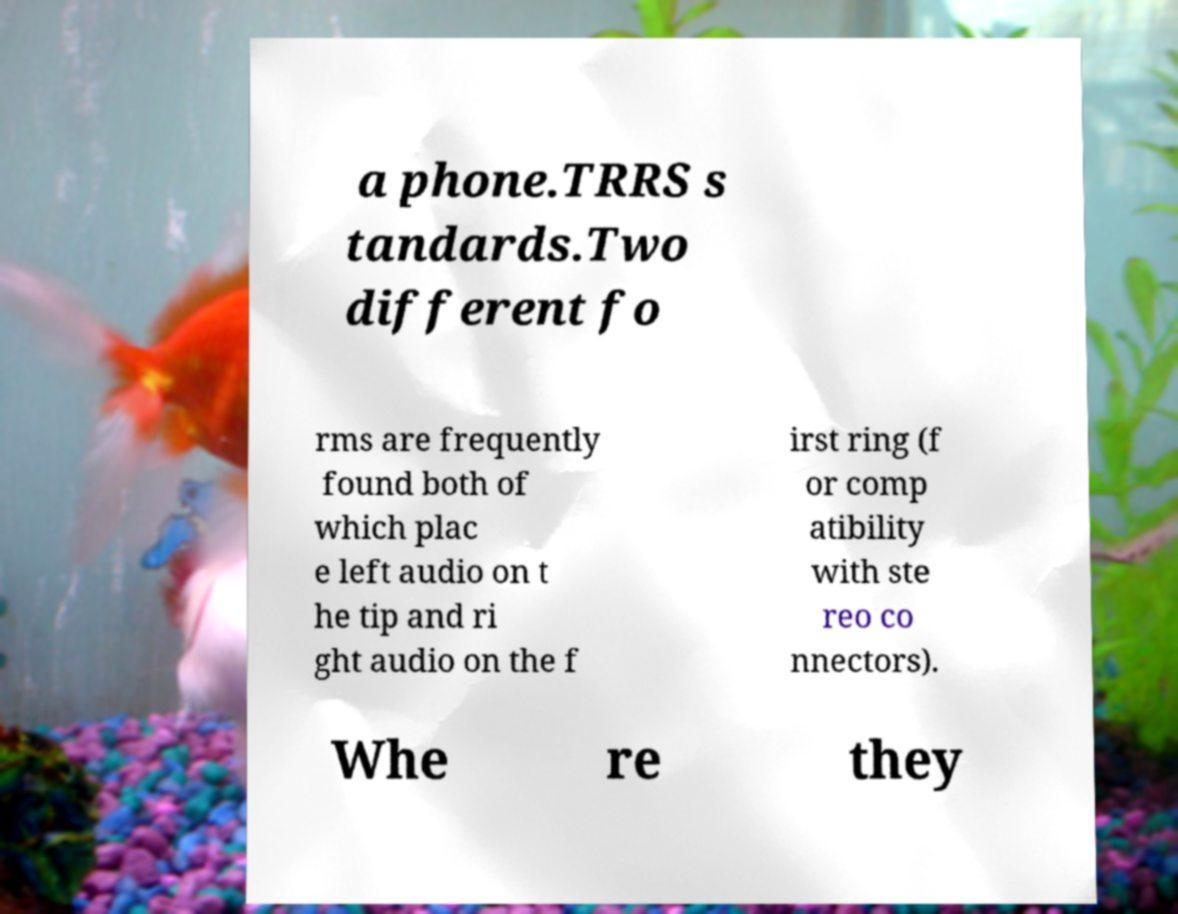Please identify and transcribe the text found in this image. a phone.TRRS s tandards.Two different fo rms are frequently found both of which plac e left audio on t he tip and ri ght audio on the f irst ring (f or comp atibility with ste reo co nnectors). Whe re they 